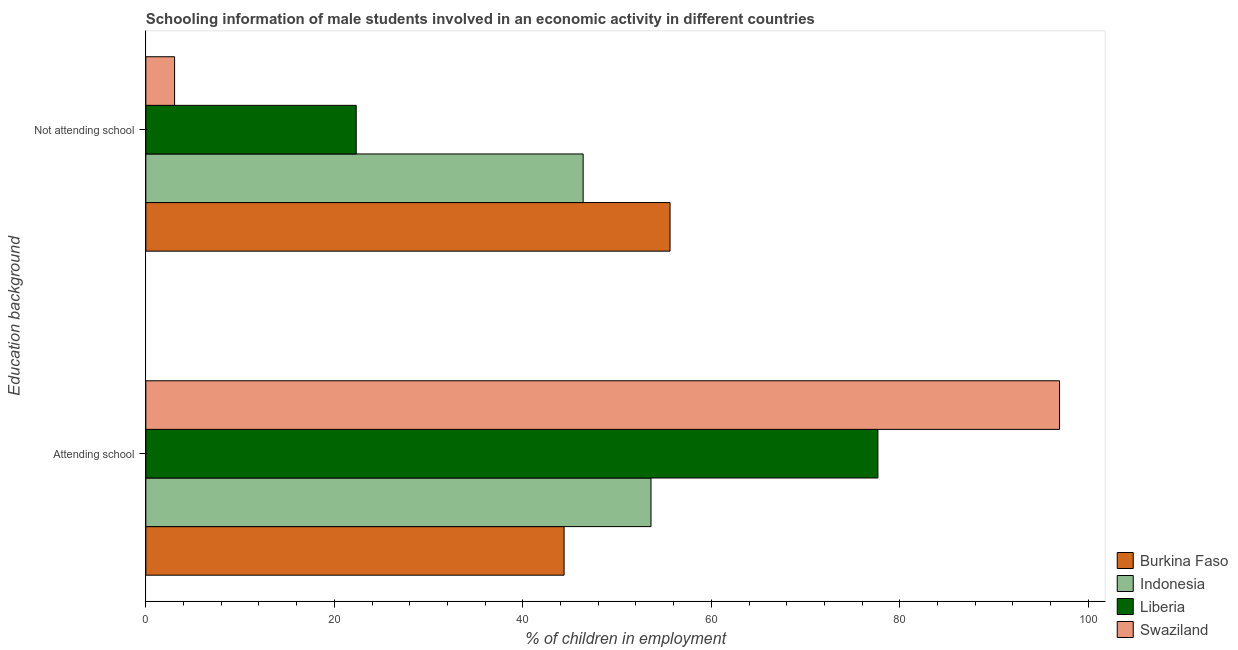How many groups of bars are there?
Your answer should be compact. 2. What is the label of the 1st group of bars from the top?
Provide a short and direct response. Not attending school. What is the percentage of employed males who are attending school in Burkina Faso?
Give a very brief answer. 44.38. Across all countries, what is the maximum percentage of employed males who are attending school?
Provide a short and direct response. 96.95. Across all countries, what is the minimum percentage of employed males who are not attending school?
Offer a very short reply. 3.05. In which country was the percentage of employed males who are attending school maximum?
Provide a short and direct response. Swaziland. In which country was the percentage of employed males who are not attending school minimum?
Your answer should be very brief. Swaziland. What is the total percentage of employed males who are attending school in the graph?
Your answer should be very brief. 272.6. What is the difference between the percentage of employed males who are not attending school in Swaziland and that in Liberia?
Offer a terse response. -19.27. What is the difference between the percentage of employed males who are attending school in Liberia and the percentage of employed males who are not attending school in Indonesia?
Offer a very short reply. 31.28. What is the average percentage of employed males who are attending school per country?
Provide a short and direct response. 68.15. What is the difference between the percentage of employed males who are not attending school and percentage of employed males who are attending school in Burkina Faso?
Make the answer very short. 11.24. In how many countries, is the percentage of employed males who are not attending school greater than 20 %?
Offer a very short reply. 3. What is the ratio of the percentage of employed males who are attending school in Indonesia to that in Swaziland?
Offer a very short reply. 0.55. What does the 1st bar from the bottom in Attending school represents?
Provide a short and direct response. Burkina Faso. Does the graph contain any zero values?
Provide a short and direct response. No. Does the graph contain grids?
Provide a succinct answer. No. Where does the legend appear in the graph?
Offer a very short reply. Bottom right. What is the title of the graph?
Offer a very short reply. Schooling information of male students involved in an economic activity in different countries. Does "Sudan" appear as one of the legend labels in the graph?
Provide a succinct answer. No. What is the label or title of the X-axis?
Provide a short and direct response. % of children in employment. What is the label or title of the Y-axis?
Give a very brief answer. Education background. What is the % of children in employment of Burkina Faso in Attending school?
Provide a short and direct response. 44.38. What is the % of children in employment in Indonesia in Attending school?
Give a very brief answer. 53.6. What is the % of children in employment of Liberia in Attending school?
Your answer should be very brief. 77.68. What is the % of children in employment in Swaziland in Attending school?
Your answer should be very brief. 96.95. What is the % of children in employment of Burkina Faso in Not attending school?
Ensure brevity in your answer.  55.62. What is the % of children in employment of Indonesia in Not attending school?
Offer a terse response. 46.4. What is the % of children in employment in Liberia in Not attending school?
Your answer should be very brief. 22.32. What is the % of children in employment of Swaziland in Not attending school?
Give a very brief answer. 3.05. Across all Education background, what is the maximum % of children in employment of Burkina Faso?
Your answer should be very brief. 55.62. Across all Education background, what is the maximum % of children in employment in Indonesia?
Provide a short and direct response. 53.6. Across all Education background, what is the maximum % of children in employment in Liberia?
Keep it short and to the point. 77.68. Across all Education background, what is the maximum % of children in employment of Swaziland?
Ensure brevity in your answer.  96.95. Across all Education background, what is the minimum % of children in employment in Burkina Faso?
Your response must be concise. 44.38. Across all Education background, what is the minimum % of children in employment in Indonesia?
Keep it short and to the point. 46.4. Across all Education background, what is the minimum % of children in employment in Liberia?
Provide a succinct answer. 22.32. Across all Education background, what is the minimum % of children in employment in Swaziland?
Keep it short and to the point. 3.05. What is the total % of children in employment of Burkina Faso in the graph?
Provide a short and direct response. 100. What is the total % of children in employment of Liberia in the graph?
Offer a very short reply. 100. What is the total % of children in employment in Swaziland in the graph?
Offer a very short reply. 100. What is the difference between the % of children in employment of Burkina Faso in Attending school and that in Not attending school?
Give a very brief answer. -11.24. What is the difference between the % of children in employment of Liberia in Attending school and that in Not attending school?
Keep it short and to the point. 55.36. What is the difference between the % of children in employment in Swaziland in Attending school and that in Not attending school?
Your answer should be very brief. 93.9. What is the difference between the % of children in employment in Burkina Faso in Attending school and the % of children in employment in Indonesia in Not attending school?
Provide a succinct answer. -2.02. What is the difference between the % of children in employment of Burkina Faso in Attending school and the % of children in employment of Liberia in Not attending school?
Provide a succinct answer. 22.06. What is the difference between the % of children in employment in Burkina Faso in Attending school and the % of children in employment in Swaziland in Not attending school?
Your response must be concise. 41.33. What is the difference between the % of children in employment in Indonesia in Attending school and the % of children in employment in Liberia in Not attending school?
Your answer should be very brief. 31.28. What is the difference between the % of children in employment in Indonesia in Attending school and the % of children in employment in Swaziland in Not attending school?
Your response must be concise. 50.55. What is the difference between the % of children in employment of Liberia in Attending school and the % of children in employment of Swaziland in Not attending school?
Your answer should be compact. 74.63. What is the average % of children in employment in Indonesia per Education background?
Offer a terse response. 50. What is the average % of children in employment of Liberia per Education background?
Provide a succinct answer. 50. What is the average % of children in employment of Swaziland per Education background?
Your answer should be very brief. 50. What is the difference between the % of children in employment of Burkina Faso and % of children in employment of Indonesia in Attending school?
Offer a very short reply. -9.22. What is the difference between the % of children in employment in Burkina Faso and % of children in employment in Liberia in Attending school?
Make the answer very short. -33.3. What is the difference between the % of children in employment in Burkina Faso and % of children in employment in Swaziland in Attending school?
Keep it short and to the point. -52.57. What is the difference between the % of children in employment in Indonesia and % of children in employment in Liberia in Attending school?
Offer a terse response. -24.08. What is the difference between the % of children in employment in Indonesia and % of children in employment in Swaziland in Attending school?
Your answer should be very brief. -43.35. What is the difference between the % of children in employment in Liberia and % of children in employment in Swaziland in Attending school?
Keep it short and to the point. -19.27. What is the difference between the % of children in employment in Burkina Faso and % of children in employment in Indonesia in Not attending school?
Your answer should be very brief. 9.22. What is the difference between the % of children in employment in Burkina Faso and % of children in employment in Liberia in Not attending school?
Offer a terse response. 33.3. What is the difference between the % of children in employment of Burkina Faso and % of children in employment of Swaziland in Not attending school?
Offer a very short reply. 52.57. What is the difference between the % of children in employment in Indonesia and % of children in employment in Liberia in Not attending school?
Your answer should be compact. 24.08. What is the difference between the % of children in employment in Indonesia and % of children in employment in Swaziland in Not attending school?
Make the answer very short. 43.35. What is the difference between the % of children in employment in Liberia and % of children in employment in Swaziland in Not attending school?
Your answer should be compact. 19.27. What is the ratio of the % of children in employment of Burkina Faso in Attending school to that in Not attending school?
Your answer should be very brief. 0.8. What is the ratio of the % of children in employment of Indonesia in Attending school to that in Not attending school?
Provide a succinct answer. 1.16. What is the ratio of the % of children in employment of Liberia in Attending school to that in Not attending school?
Make the answer very short. 3.48. What is the ratio of the % of children in employment in Swaziland in Attending school to that in Not attending school?
Give a very brief answer. 31.77. What is the difference between the highest and the second highest % of children in employment in Burkina Faso?
Provide a succinct answer. 11.24. What is the difference between the highest and the second highest % of children in employment in Liberia?
Give a very brief answer. 55.36. What is the difference between the highest and the second highest % of children in employment in Swaziland?
Ensure brevity in your answer.  93.9. What is the difference between the highest and the lowest % of children in employment in Burkina Faso?
Give a very brief answer. 11.24. What is the difference between the highest and the lowest % of children in employment of Liberia?
Offer a terse response. 55.36. What is the difference between the highest and the lowest % of children in employment in Swaziland?
Provide a short and direct response. 93.9. 